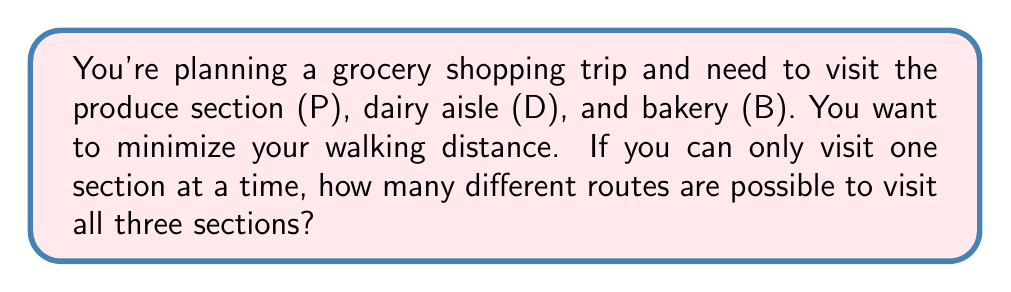Show me your answer to this math problem. Let's approach this step-by-step using Boolean algebra concepts:

1) First, we need to understand that the order of visiting matters. This is a permutation problem.

2) We have 3 distinct sections to visit: P, D, and B.

3) For the first stop, we have 3 choices.

4) For the second stop, we have 2 remaining choices.

5) For the last stop, we only have 1 choice left.

6) In Boolean algebra, we use the multiplication principle when we have a sequence of choices. This principle states that if we have $m$ ways of doing something and $n$ ways of doing another thing, then there are $m \times n$ ways of doing both.

7) Applying this principle to our problem:
   $$\text{Number of routes} = 3 \times 2 \times 1 = 6$$

8) We can list out all possible routes to verify:
   - P → D → B
   - P → B → D
   - D → P → B
   - D → B → P
   - B → P → D
   - B → D → P

Therefore, there are 6 different possible routes to visit all three sections.
Answer: 6 routes 